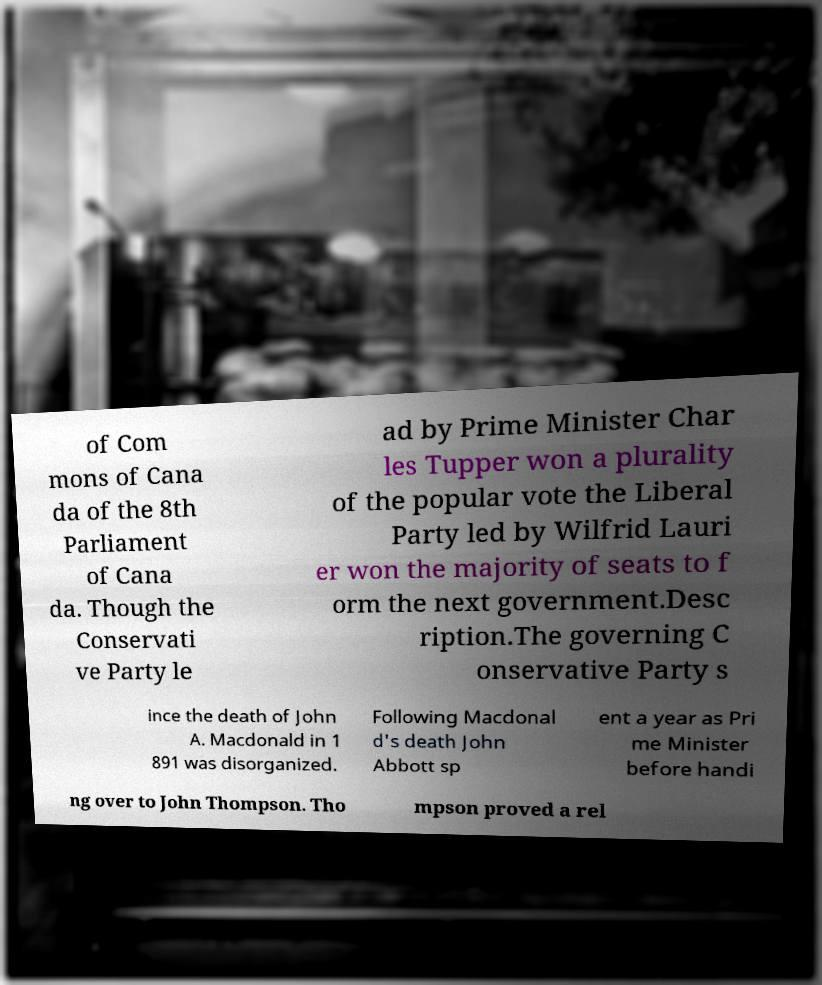Please identify and transcribe the text found in this image. of Com mons of Cana da of the 8th Parliament of Cana da. Though the Conservati ve Party le ad by Prime Minister Char les Tupper won a plurality of the popular vote the Liberal Party led by Wilfrid Lauri er won the majority of seats to f orm the next government.Desc ription.The governing C onservative Party s ince the death of John A. Macdonald in 1 891 was disorganized. Following Macdonal d's death John Abbott sp ent a year as Pri me Minister before handi ng over to John Thompson. Tho mpson proved a rel 